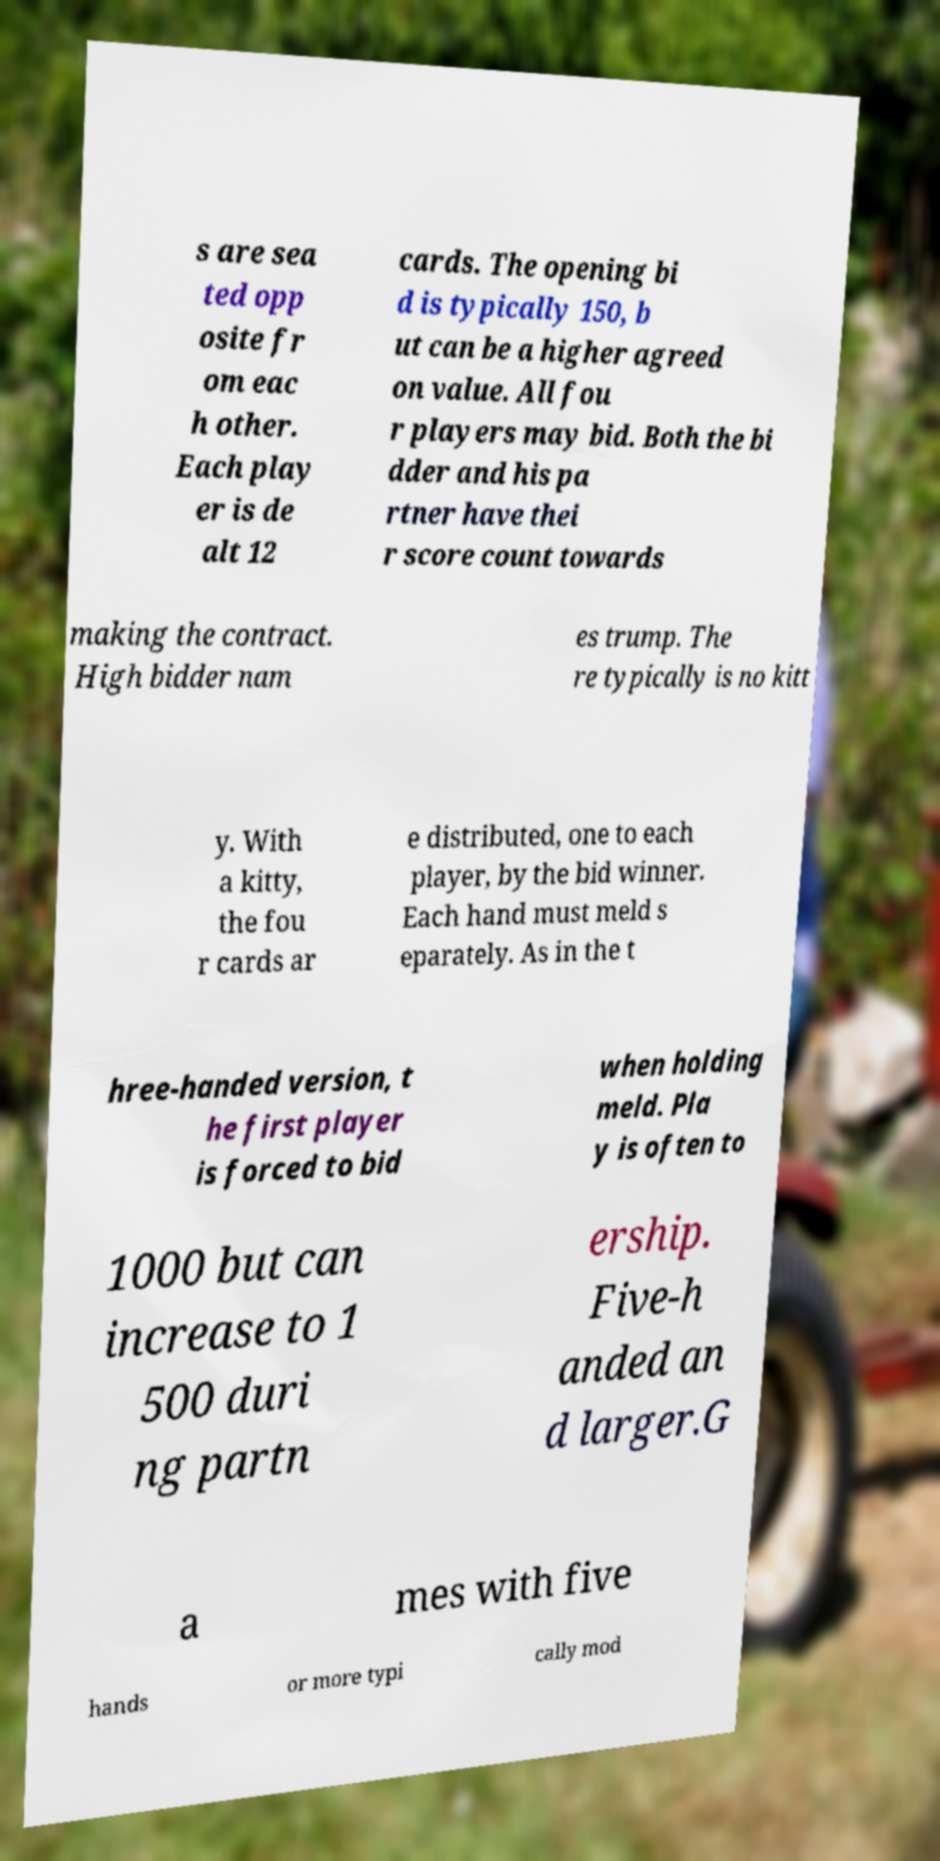Please read and relay the text visible in this image. What does it say? s are sea ted opp osite fr om eac h other. Each play er is de alt 12 cards. The opening bi d is typically 150, b ut can be a higher agreed on value. All fou r players may bid. Both the bi dder and his pa rtner have thei r score count towards making the contract. High bidder nam es trump. The re typically is no kitt y. With a kitty, the fou r cards ar e distributed, one to each player, by the bid winner. Each hand must meld s eparately. As in the t hree-handed version, t he first player is forced to bid when holding meld. Pla y is often to 1000 but can increase to 1 500 duri ng partn ership. Five-h anded an d larger.G a mes with five hands or more typi cally mod 